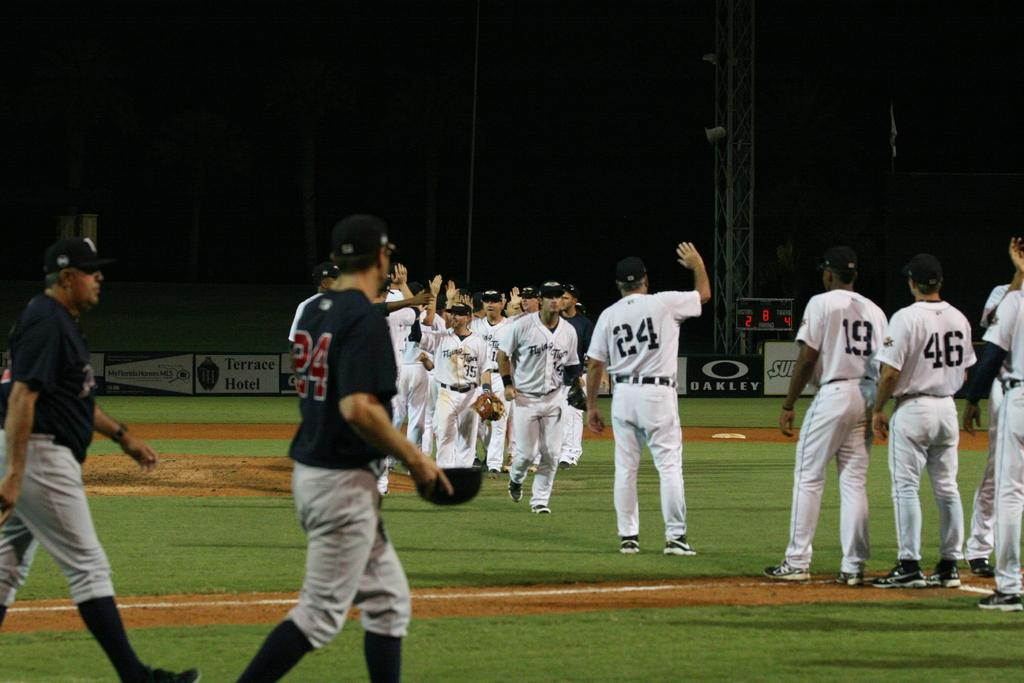<image>
Offer a succinct explanation of the picture presented. Oakley is one of the sponsors for the baseball team. 